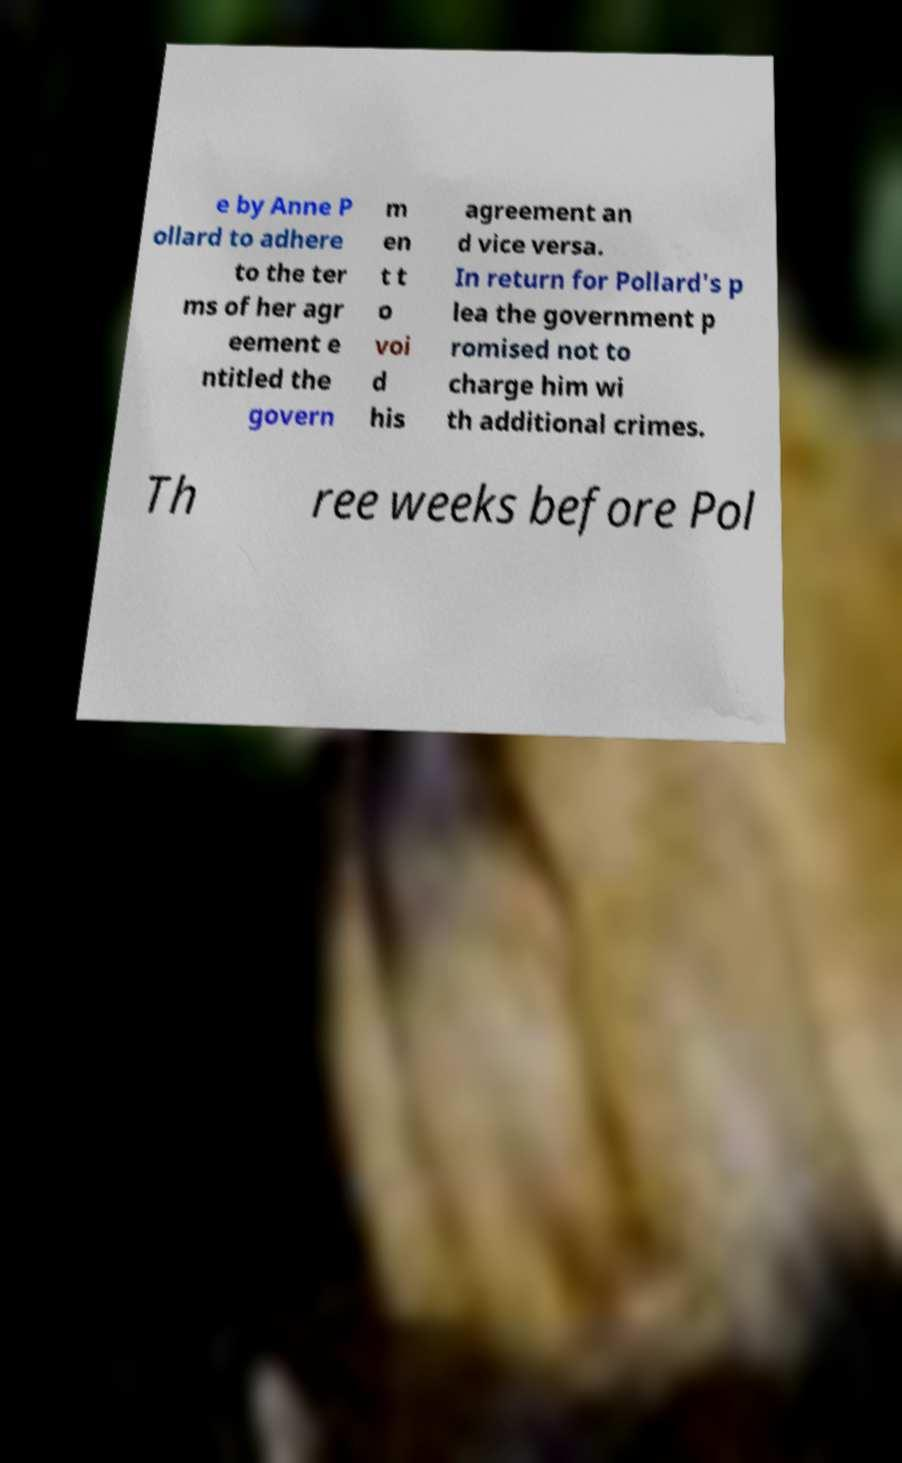Can you read and provide the text displayed in the image?This photo seems to have some interesting text. Can you extract and type it out for me? e by Anne P ollard to adhere to the ter ms of her agr eement e ntitled the govern m en t t o voi d his agreement an d vice versa. In return for Pollard's p lea the government p romised not to charge him wi th additional crimes. Th ree weeks before Pol 